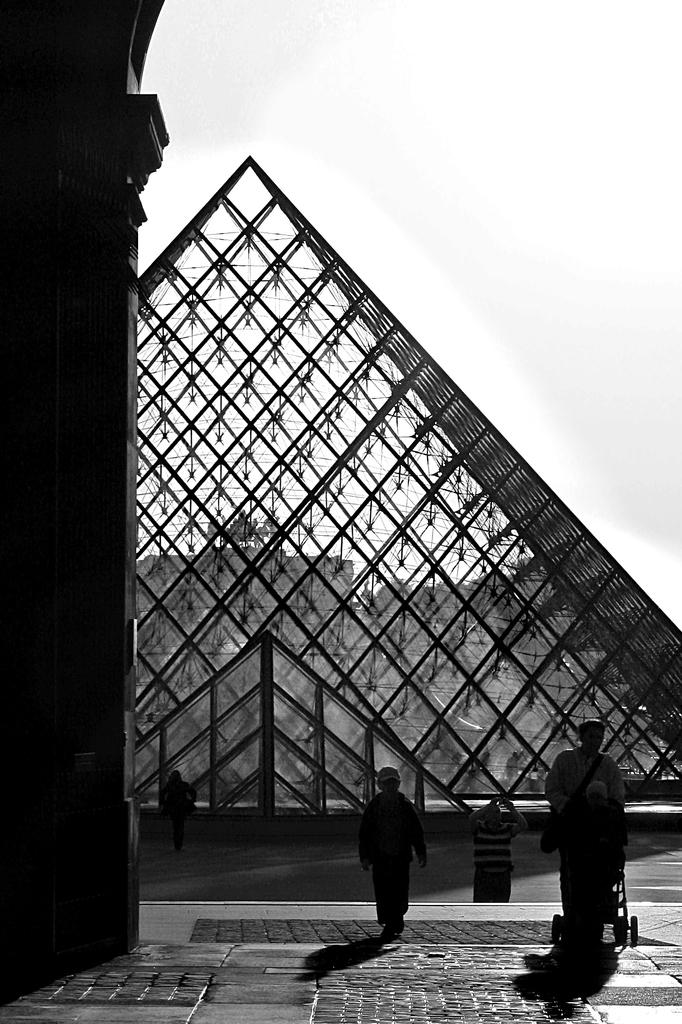What is the color scheme of the image? The image is black and white. What can be seen in the image besides the color scheme? There are people and a pillar in the image. What type of architectural feature is present in the image? There is a glass roof in the image. What is visible in the background of the image? The sky is visible in the background of the image. Where is the box located in the image? There is no box present in the image. What type of bird can be seen flying in the image? There is no bird visible in the image. 